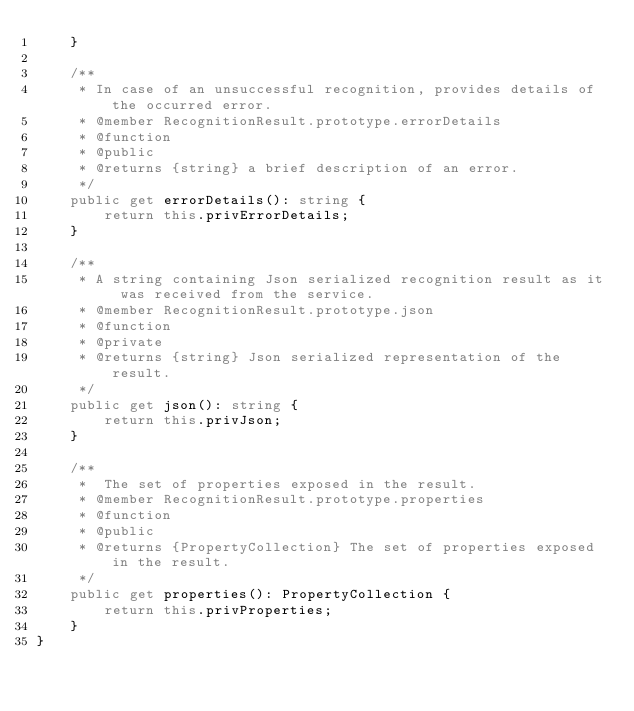<code> <loc_0><loc_0><loc_500><loc_500><_TypeScript_>    }

    /**
     * In case of an unsuccessful recognition, provides details of the occurred error.
     * @member RecognitionResult.prototype.errorDetails
     * @function
     * @public
     * @returns {string} a brief description of an error.
     */
    public get errorDetails(): string {
        return this.privErrorDetails;
    }

    /**
     * A string containing Json serialized recognition result as it was received from the service.
     * @member RecognitionResult.prototype.json
     * @function
     * @private
     * @returns {string} Json serialized representation of the result.
     */
    public get json(): string {
        return this.privJson;
    }

    /**
     *  The set of properties exposed in the result.
     * @member RecognitionResult.prototype.properties
     * @function
     * @public
     * @returns {PropertyCollection} The set of properties exposed in the result.
     */
    public get properties(): PropertyCollection {
        return this.privProperties;
    }
}
</code> 